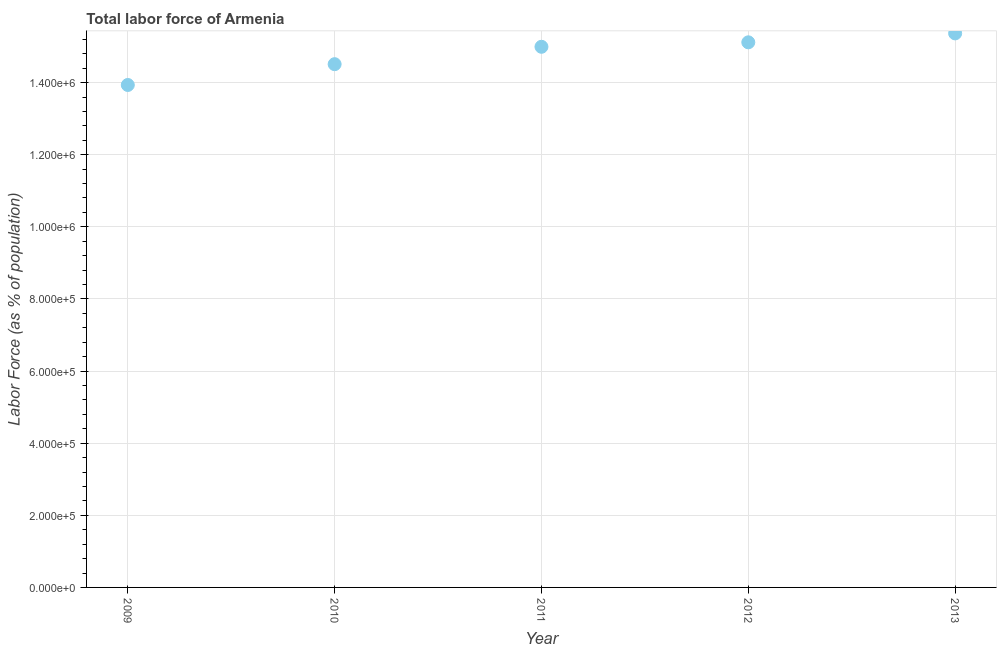What is the total labor force in 2009?
Provide a succinct answer. 1.39e+06. Across all years, what is the maximum total labor force?
Your response must be concise. 1.54e+06. Across all years, what is the minimum total labor force?
Offer a very short reply. 1.39e+06. In which year was the total labor force maximum?
Give a very brief answer. 2013. What is the sum of the total labor force?
Offer a terse response. 7.39e+06. What is the difference between the total labor force in 2011 and 2012?
Your response must be concise. -1.24e+04. What is the average total labor force per year?
Your answer should be very brief. 1.48e+06. What is the median total labor force?
Offer a terse response. 1.50e+06. What is the ratio of the total labor force in 2009 to that in 2012?
Your answer should be very brief. 0.92. Is the total labor force in 2010 less than that in 2011?
Keep it short and to the point. Yes. Is the difference between the total labor force in 2010 and 2013 greater than the difference between any two years?
Provide a succinct answer. No. What is the difference between the highest and the second highest total labor force?
Your answer should be very brief. 2.47e+04. What is the difference between the highest and the lowest total labor force?
Your response must be concise. 1.43e+05. In how many years, is the total labor force greater than the average total labor force taken over all years?
Your answer should be compact. 3. How many dotlines are there?
Offer a terse response. 1. How many years are there in the graph?
Provide a succinct answer. 5. Does the graph contain any zero values?
Your answer should be very brief. No. What is the title of the graph?
Offer a terse response. Total labor force of Armenia. What is the label or title of the X-axis?
Keep it short and to the point. Year. What is the label or title of the Y-axis?
Keep it short and to the point. Labor Force (as % of population). What is the Labor Force (as % of population) in 2009?
Make the answer very short. 1.39e+06. What is the Labor Force (as % of population) in 2010?
Your answer should be very brief. 1.45e+06. What is the Labor Force (as % of population) in 2011?
Provide a short and direct response. 1.50e+06. What is the Labor Force (as % of population) in 2012?
Offer a very short reply. 1.51e+06. What is the Labor Force (as % of population) in 2013?
Offer a very short reply. 1.54e+06. What is the difference between the Labor Force (as % of population) in 2009 and 2010?
Provide a short and direct response. -5.77e+04. What is the difference between the Labor Force (as % of population) in 2009 and 2011?
Your answer should be very brief. -1.06e+05. What is the difference between the Labor Force (as % of population) in 2009 and 2012?
Offer a terse response. -1.18e+05. What is the difference between the Labor Force (as % of population) in 2009 and 2013?
Make the answer very short. -1.43e+05. What is the difference between the Labor Force (as % of population) in 2010 and 2011?
Ensure brevity in your answer.  -4.82e+04. What is the difference between the Labor Force (as % of population) in 2010 and 2012?
Your answer should be compact. -6.06e+04. What is the difference between the Labor Force (as % of population) in 2010 and 2013?
Your answer should be very brief. -8.54e+04. What is the difference between the Labor Force (as % of population) in 2011 and 2012?
Your response must be concise. -1.24e+04. What is the difference between the Labor Force (as % of population) in 2011 and 2013?
Offer a very short reply. -3.71e+04. What is the difference between the Labor Force (as % of population) in 2012 and 2013?
Your response must be concise. -2.47e+04. What is the ratio of the Labor Force (as % of population) in 2009 to that in 2010?
Make the answer very short. 0.96. What is the ratio of the Labor Force (as % of population) in 2009 to that in 2011?
Your answer should be compact. 0.93. What is the ratio of the Labor Force (as % of population) in 2009 to that in 2012?
Give a very brief answer. 0.92. What is the ratio of the Labor Force (as % of population) in 2009 to that in 2013?
Your answer should be very brief. 0.91. What is the ratio of the Labor Force (as % of population) in 2010 to that in 2012?
Your answer should be very brief. 0.96. What is the ratio of the Labor Force (as % of population) in 2010 to that in 2013?
Ensure brevity in your answer.  0.94. What is the ratio of the Labor Force (as % of population) in 2011 to that in 2012?
Your answer should be compact. 0.99. What is the ratio of the Labor Force (as % of population) in 2011 to that in 2013?
Your response must be concise. 0.98. 